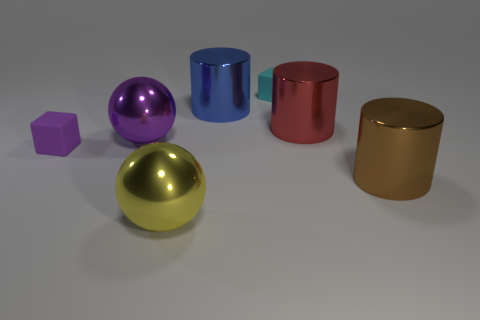Add 1 shiny objects. How many objects exist? 8 Subtract all balls. How many objects are left? 5 Subtract all large purple things. Subtract all big yellow balls. How many objects are left? 5 Add 1 purple metallic objects. How many purple metallic objects are left? 2 Add 2 tiny blue metallic cubes. How many tiny blue metallic cubes exist? 2 Subtract 0 yellow cubes. How many objects are left? 7 